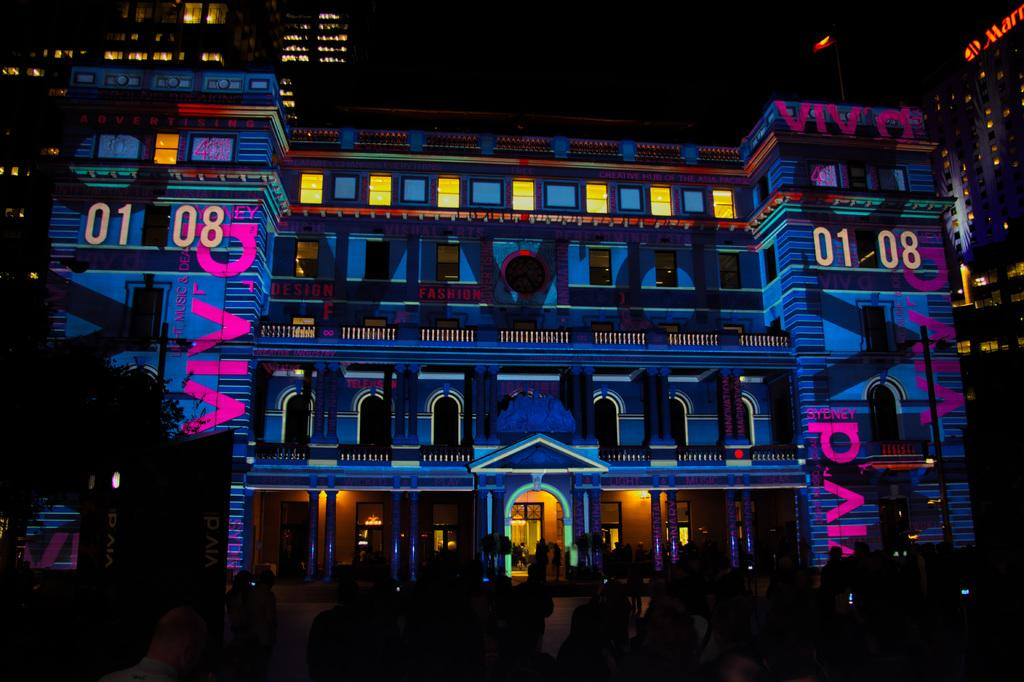How many people are in the group that is visible in the image? There is a group of people standing in the image, but the exact number cannot be determined from the provided facts. What type of structures can be seen in the image? There are buildings with windows in the image. What can be seen illuminated in the image? Lights are visible in the image. What type of vertical structures are present in the image? Poles are present in the image. What type of plant is visible in the image? There is a tree in the image. What other objects can be seen in the image? There are other objects in the image, but their specific nature cannot be determined from the provided facts. What is the color of the background in the image? The background of the image is dark. What type of berry is being used to decorate the pie in the image? There is no pie or berry present in the image. Can you describe the behavior of the squirrel in the image? There is no squirrel present in the image. 